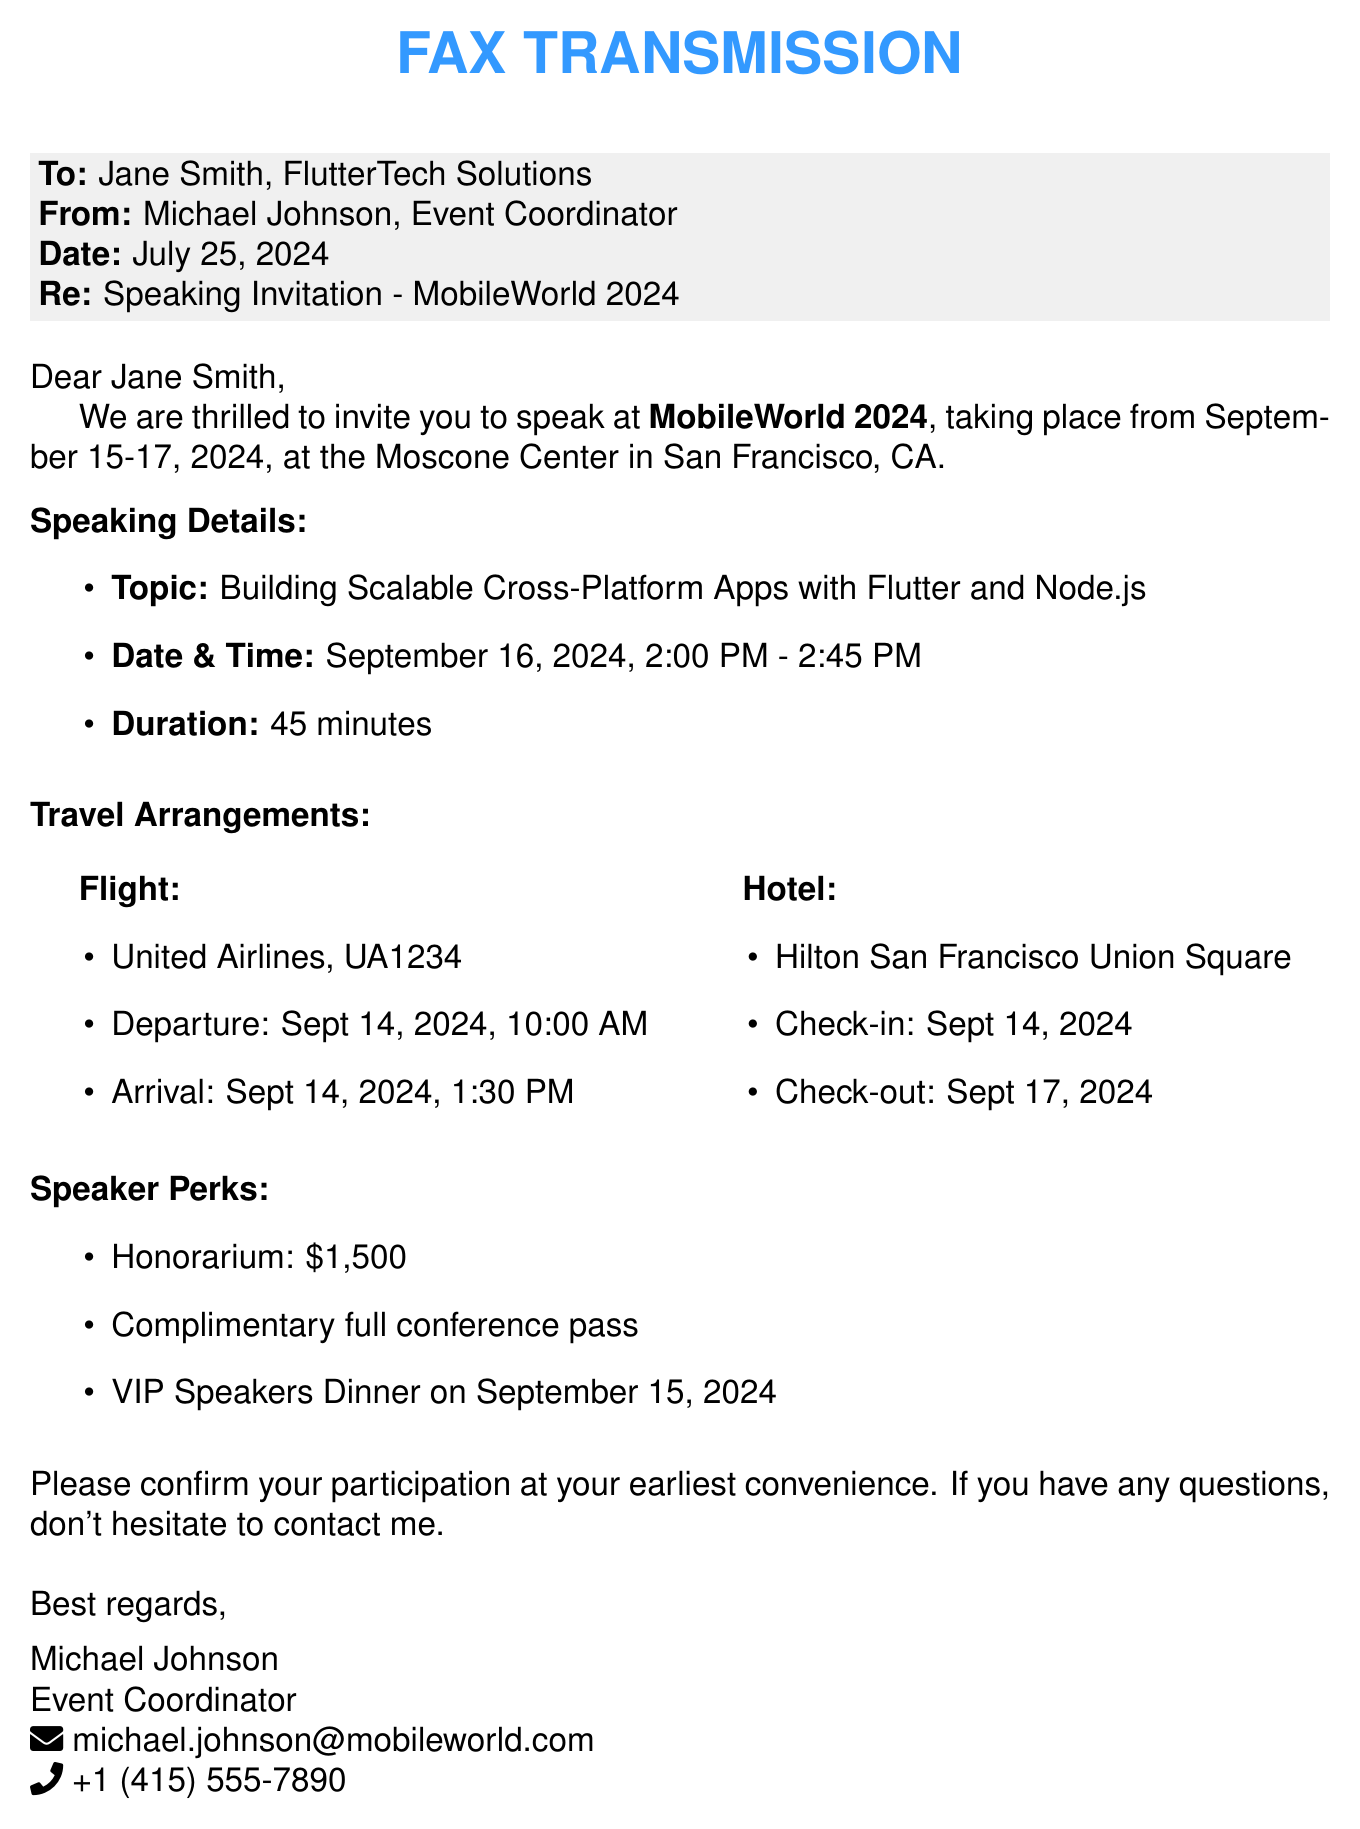What is the name of the event? The event is referred to as MobileWorld 2024 in the document.
Answer: MobileWorld 2024 What is the topic of the speech? The speech is about Building Scalable Cross-Platform Apps with Flutter and Node.js.
Answer: Building Scalable Cross-Platform Apps with Flutter and Node.js What are the travel dates? The travel dates include departure on Sept 14, 2024, and return on Sept 17, 2024.
Answer: Sept 14-17, 2024 What is the honorarium for the speaker? The document specifies that the honorarium is $1,500.
Answer: $1,500 What is the date and time of the speech? The speech is scheduled for September 16, 2024, from 2:00 PM to 2:45 PM.
Answer: September 16, 2024, 2:00 PM - 2:45 PM Who should confirm participation? The document indicates that Jane Smith should confirm her participation.
Answer: Jane Smith What hotel will the speaker be staying in? The speaker will be staying at the Hilton San Francisco Union Square.
Answer: Hilton San Francisco Union Square When is the VIP Speakers Dinner? The VIP Speakers Dinner is on September 15, 2024.
Answer: September 15, 2024 